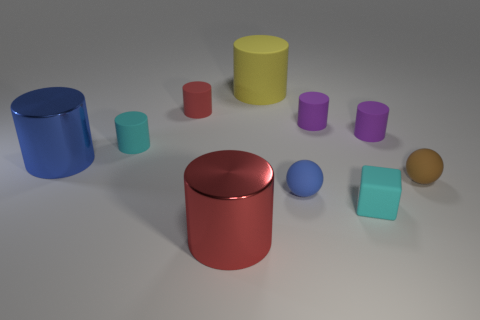Subtract all blue cylinders. How many cylinders are left? 6 Subtract all yellow cylinders. How many cylinders are left? 6 Subtract all gray cylinders. Subtract all yellow blocks. How many cylinders are left? 7 Subtract all spheres. How many objects are left? 8 Add 6 small cyan things. How many small cyan things exist? 8 Subtract 0 red blocks. How many objects are left? 10 Subtract all big blue objects. Subtract all tiny cyan shiny cylinders. How many objects are left? 9 Add 4 big blue cylinders. How many big blue cylinders are left? 5 